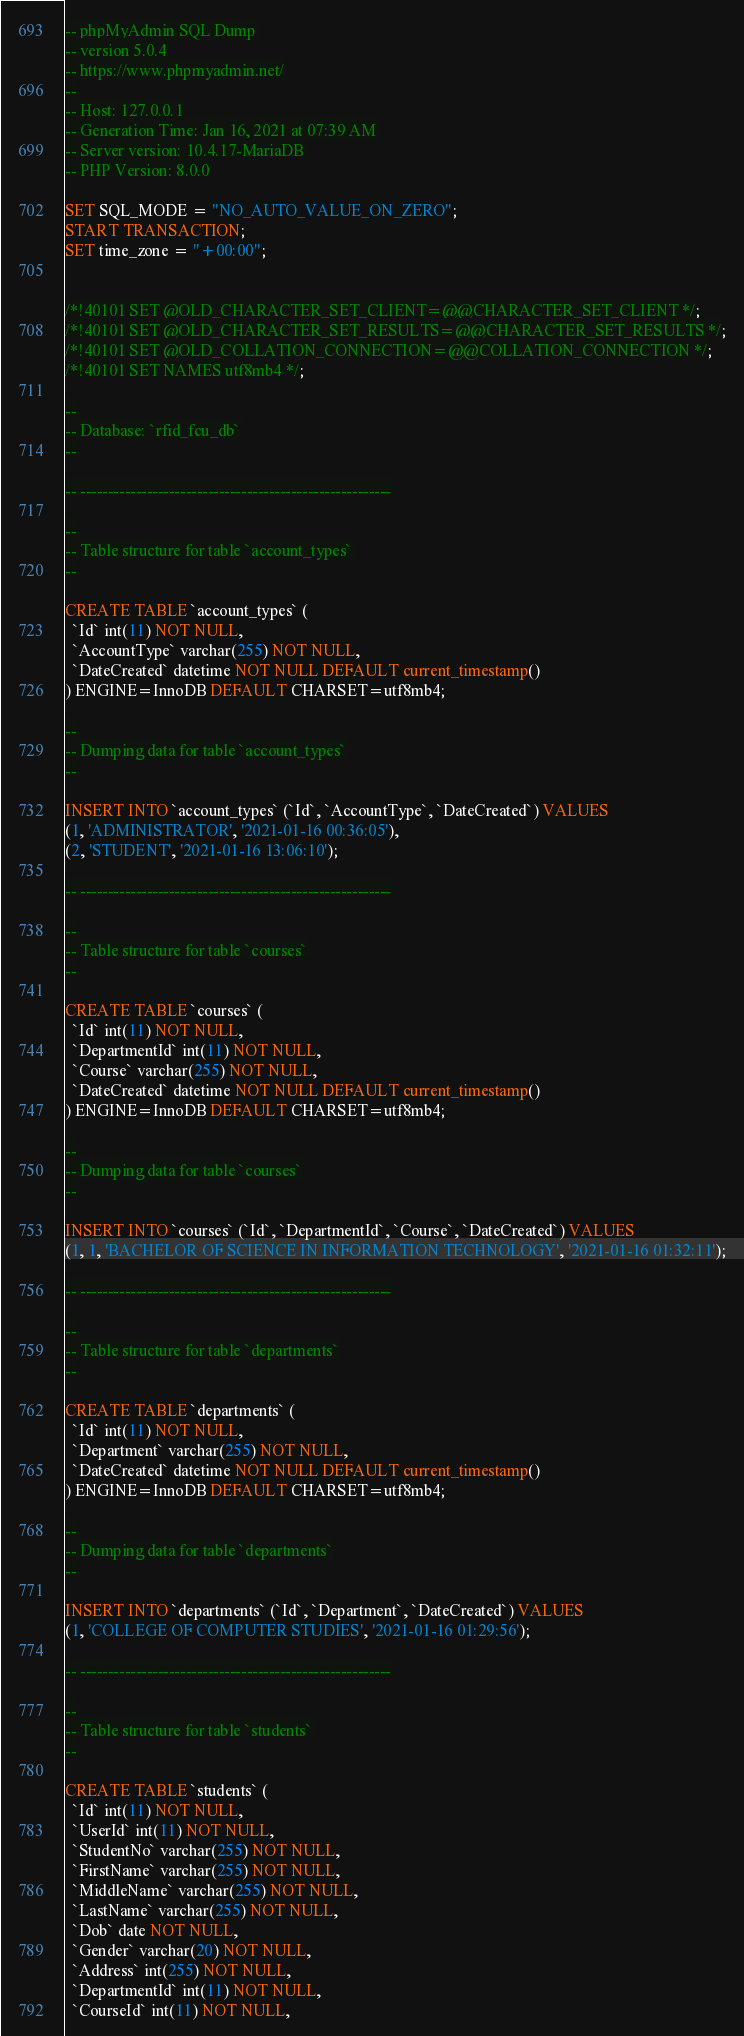Convert code to text. <code><loc_0><loc_0><loc_500><loc_500><_SQL_>-- phpMyAdmin SQL Dump
-- version 5.0.4
-- https://www.phpmyadmin.net/
--
-- Host: 127.0.0.1
-- Generation Time: Jan 16, 2021 at 07:39 AM
-- Server version: 10.4.17-MariaDB
-- PHP Version: 8.0.0

SET SQL_MODE = "NO_AUTO_VALUE_ON_ZERO";
START TRANSACTION;
SET time_zone = "+00:00";


/*!40101 SET @OLD_CHARACTER_SET_CLIENT=@@CHARACTER_SET_CLIENT */;
/*!40101 SET @OLD_CHARACTER_SET_RESULTS=@@CHARACTER_SET_RESULTS */;
/*!40101 SET @OLD_COLLATION_CONNECTION=@@COLLATION_CONNECTION */;
/*!40101 SET NAMES utf8mb4 */;

--
-- Database: `rfid_fcu_db`
--

-- --------------------------------------------------------

--
-- Table structure for table `account_types`
--

CREATE TABLE `account_types` (
  `Id` int(11) NOT NULL,
  `AccountType` varchar(255) NOT NULL,
  `DateCreated` datetime NOT NULL DEFAULT current_timestamp()
) ENGINE=InnoDB DEFAULT CHARSET=utf8mb4;

--
-- Dumping data for table `account_types`
--

INSERT INTO `account_types` (`Id`, `AccountType`, `DateCreated`) VALUES
(1, 'ADMINISTRATOR', '2021-01-16 00:36:05'),
(2, 'STUDENT', '2021-01-16 13:06:10');

-- --------------------------------------------------------

--
-- Table structure for table `courses`
--

CREATE TABLE `courses` (
  `Id` int(11) NOT NULL,
  `DepartmentId` int(11) NOT NULL,
  `Course` varchar(255) NOT NULL,
  `DateCreated` datetime NOT NULL DEFAULT current_timestamp()
) ENGINE=InnoDB DEFAULT CHARSET=utf8mb4;

--
-- Dumping data for table `courses`
--

INSERT INTO `courses` (`Id`, `DepartmentId`, `Course`, `DateCreated`) VALUES
(1, 1, 'BACHELOR OF SCIENCE IN INFORMATION TECHNOLOGY', '2021-01-16 01:32:11');

-- --------------------------------------------------------

--
-- Table structure for table `departments`
--

CREATE TABLE `departments` (
  `Id` int(11) NOT NULL,
  `Department` varchar(255) NOT NULL,
  `DateCreated` datetime NOT NULL DEFAULT current_timestamp()
) ENGINE=InnoDB DEFAULT CHARSET=utf8mb4;

--
-- Dumping data for table `departments`
--

INSERT INTO `departments` (`Id`, `Department`, `DateCreated`) VALUES
(1, 'COLLEGE OF COMPUTER STUDIES', '2021-01-16 01:29:56');

-- --------------------------------------------------------

--
-- Table structure for table `students`
--

CREATE TABLE `students` (
  `Id` int(11) NOT NULL,
  `UserId` int(11) NOT NULL,
  `StudentNo` varchar(255) NOT NULL,
  `FirstName` varchar(255) NOT NULL,
  `MiddleName` varchar(255) NOT NULL,
  `LastName` varchar(255) NOT NULL,
  `Dob` date NOT NULL,
  `Gender` varchar(20) NOT NULL,
  `Address` int(255) NOT NULL,
  `DepartmentId` int(11) NOT NULL,
  `CourseId` int(11) NOT NULL,</code> 